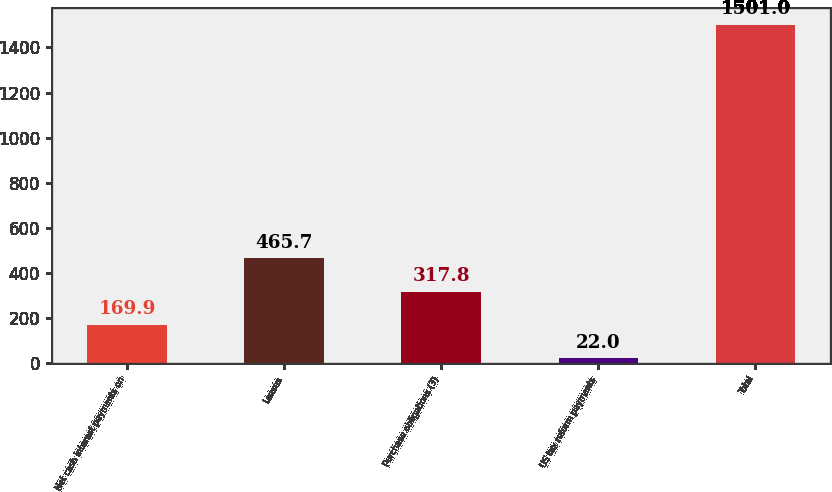Convert chart to OTSL. <chart><loc_0><loc_0><loc_500><loc_500><bar_chart><fcel>Net cash interest payments on<fcel>Leases<fcel>Purchase obligations (3)<fcel>US tax reform payments<fcel>Total<nl><fcel>169.9<fcel>465.7<fcel>317.8<fcel>22<fcel>1501<nl></chart> 